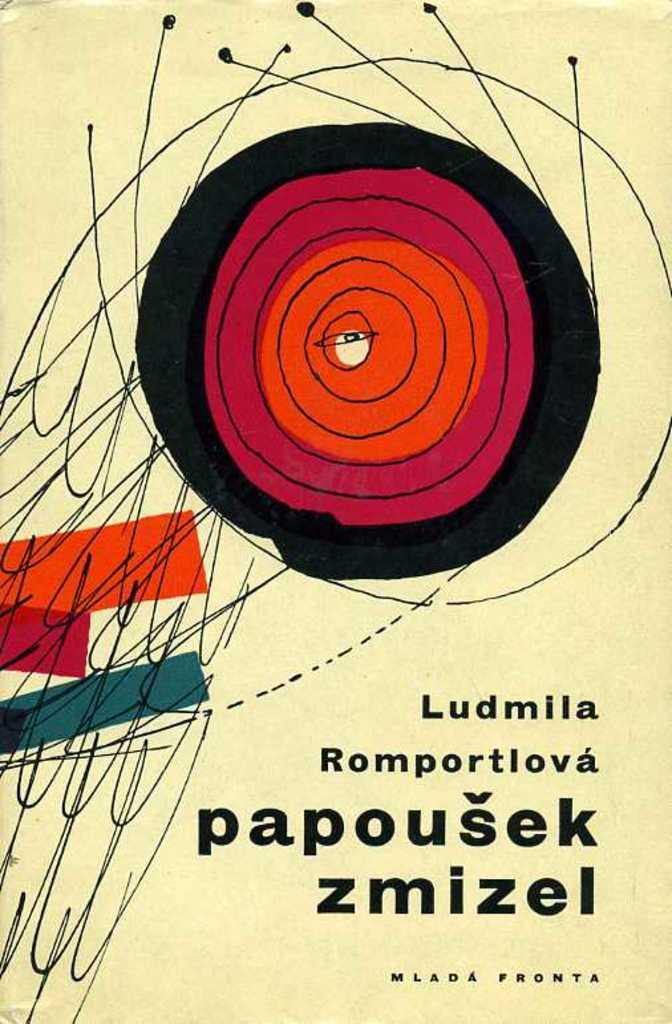<image>
Offer a succinct explanation of the picture presented. A picture is labeled "Ludmila Romportlova papousek zmizel." 